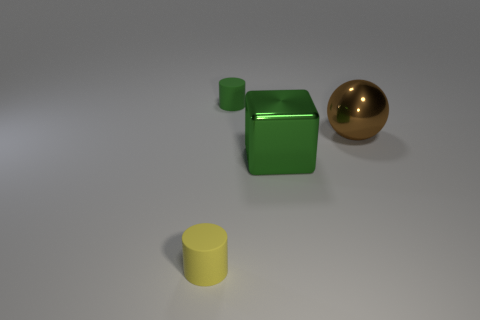Add 1 tiny rubber cylinders. How many objects exist? 5 Subtract 0 brown cubes. How many objects are left? 4 Subtract all blue cylinders. Subtract all green blocks. How many cylinders are left? 2 Subtract all brown balls. How many blue cylinders are left? 0 Subtract all green rubber objects. Subtract all brown spheres. How many objects are left? 2 Add 3 spheres. How many spheres are left? 4 Add 1 green blocks. How many green blocks exist? 2 Subtract all green cylinders. How many cylinders are left? 1 